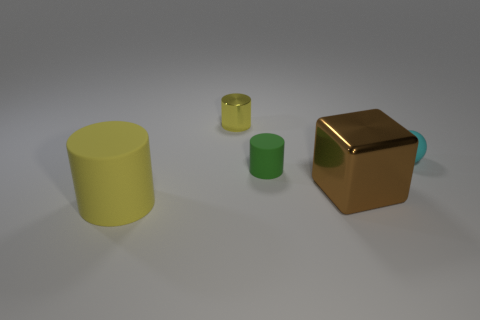Is there any other thing that has the same shape as the brown thing?
Provide a short and direct response. No. Does the matte object to the left of the small yellow object have the same color as the metal cylinder?
Your response must be concise. Yes. How many other objects are the same size as the brown metallic thing?
Give a very brief answer. 1. Are the tiny green cylinder and the small yellow thing made of the same material?
Ensure brevity in your answer.  No. There is a cylinder in front of the big thing that is behind the large cylinder; what is its color?
Offer a very short reply. Yellow. There is another matte object that is the same shape as the green matte thing; what size is it?
Ensure brevity in your answer.  Large. Is the large matte object the same color as the tiny metallic cylinder?
Ensure brevity in your answer.  Yes. What number of small cyan rubber things are in front of the small cylinder behind the matte object that is right of the brown shiny thing?
Provide a succinct answer. 1. Is the number of big brown shiny things greater than the number of big blue metallic balls?
Your answer should be very brief. Yes. What number of small yellow objects are there?
Your answer should be compact. 1. 